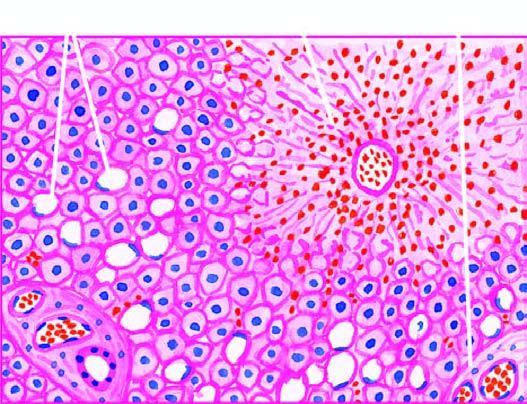does the peripheral zone show mild fatty change of liver cells?
Answer the question using a single word or phrase. Yes 